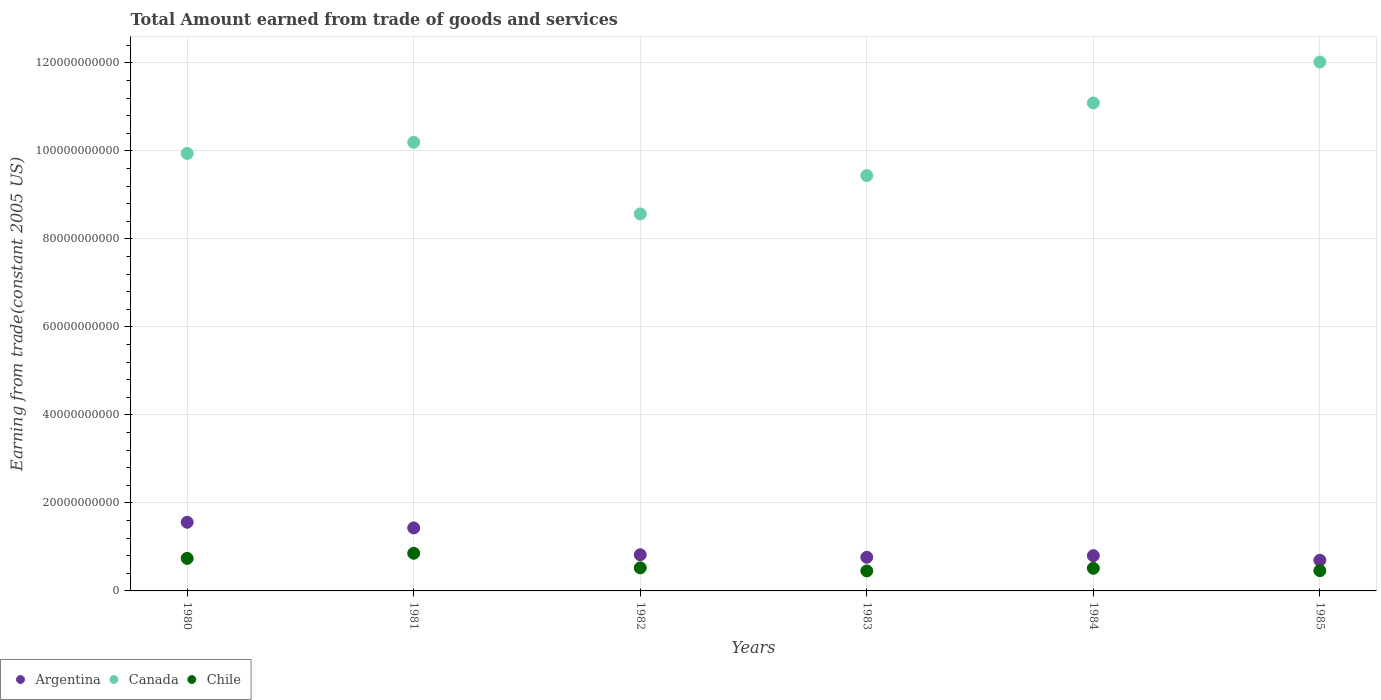What is the total amount earned by trading goods and services in Canada in 1980?
Give a very brief answer. 9.94e+1. Across all years, what is the maximum total amount earned by trading goods and services in Chile?
Ensure brevity in your answer.  8.56e+09. Across all years, what is the minimum total amount earned by trading goods and services in Canada?
Offer a terse response. 8.57e+1. In which year was the total amount earned by trading goods and services in Argentina maximum?
Provide a short and direct response. 1980. What is the total total amount earned by trading goods and services in Argentina in the graph?
Offer a terse response. 6.08e+1. What is the difference between the total amount earned by trading goods and services in Chile in 1980 and that in 1982?
Provide a short and direct response. 2.15e+09. What is the difference between the total amount earned by trading goods and services in Chile in 1984 and the total amount earned by trading goods and services in Canada in 1980?
Ensure brevity in your answer.  -9.43e+1. What is the average total amount earned by trading goods and services in Argentina per year?
Offer a very short reply. 1.01e+1. In the year 1981, what is the difference between the total amount earned by trading goods and services in Argentina and total amount earned by trading goods and services in Chile?
Offer a terse response. 5.76e+09. What is the ratio of the total amount earned by trading goods and services in Canada in 1982 to that in 1984?
Your answer should be very brief. 0.77. What is the difference between the highest and the second highest total amount earned by trading goods and services in Chile?
Provide a short and direct response. 1.16e+09. What is the difference between the highest and the lowest total amount earned by trading goods and services in Argentina?
Make the answer very short. 8.64e+09. Is the sum of the total amount earned by trading goods and services in Canada in 1981 and 1982 greater than the maximum total amount earned by trading goods and services in Chile across all years?
Keep it short and to the point. Yes. Is it the case that in every year, the sum of the total amount earned by trading goods and services in Argentina and total amount earned by trading goods and services in Chile  is greater than the total amount earned by trading goods and services in Canada?
Provide a succinct answer. No. Is the total amount earned by trading goods and services in Canada strictly greater than the total amount earned by trading goods and services in Argentina over the years?
Provide a succinct answer. Yes. How many dotlines are there?
Offer a terse response. 3. Are the values on the major ticks of Y-axis written in scientific E-notation?
Keep it short and to the point. No. Does the graph contain grids?
Give a very brief answer. Yes. How are the legend labels stacked?
Offer a terse response. Horizontal. What is the title of the graph?
Your response must be concise. Total Amount earned from trade of goods and services. What is the label or title of the X-axis?
Provide a short and direct response. Years. What is the label or title of the Y-axis?
Provide a succinct answer. Earning from trade(constant 2005 US). What is the Earning from trade(constant 2005 US) in Argentina in 1980?
Offer a very short reply. 1.56e+1. What is the Earning from trade(constant 2005 US) in Canada in 1980?
Provide a succinct answer. 9.94e+1. What is the Earning from trade(constant 2005 US) of Chile in 1980?
Ensure brevity in your answer.  7.40e+09. What is the Earning from trade(constant 2005 US) in Argentina in 1981?
Offer a very short reply. 1.43e+1. What is the Earning from trade(constant 2005 US) in Canada in 1981?
Your answer should be compact. 1.02e+11. What is the Earning from trade(constant 2005 US) in Chile in 1981?
Give a very brief answer. 8.56e+09. What is the Earning from trade(constant 2005 US) of Argentina in 1982?
Your response must be concise. 8.22e+09. What is the Earning from trade(constant 2005 US) in Canada in 1982?
Provide a short and direct response. 8.57e+1. What is the Earning from trade(constant 2005 US) of Chile in 1982?
Offer a very short reply. 5.24e+09. What is the Earning from trade(constant 2005 US) in Argentina in 1983?
Offer a terse response. 7.65e+09. What is the Earning from trade(constant 2005 US) in Canada in 1983?
Provide a short and direct response. 9.44e+1. What is the Earning from trade(constant 2005 US) in Chile in 1983?
Give a very brief answer. 4.54e+09. What is the Earning from trade(constant 2005 US) of Argentina in 1984?
Offer a very short reply. 8.01e+09. What is the Earning from trade(constant 2005 US) of Canada in 1984?
Ensure brevity in your answer.  1.11e+11. What is the Earning from trade(constant 2005 US) in Chile in 1984?
Your answer should be very brief. 5.14e+09. What is the Earning from trade(constant 2005 US) of Argentina in 1985?
Offer a terse response. 6.97e+09. What is the Earning from trade(constant 2005 US) of Canada in 1985?
Offer a very short reply. 1.20e+11. What is the Earning from trade(constant 2005 US) of Chile in 1985?
Provide a short and direct response. 4.61e+09. Across all years, what is the maximum Earning from trade(constant 2005 US) of Argentina?
Ensure brevity in your answer.  1.56e+1. Across all years, what is the maximum Earning from trade(constant 2005 US) in Canada?
Offer a terse response. 1.20e+11. Across all years, what is the maximum Earning from trade(constant 2005 US) of Chile?
Your answer should be compact. 8.56e+09. Across all years, what is the minimum Earning from trade(constant 2005 US) of Argentina?
Ensure brevity in your answer.  6.97e+09. Across all years, what is the minimum Earning from trade(constant 2005 US) in Canada?
Provide a succinct answer. 8.57e+1. Across all years, what is the minimum Earning from trade(constant 2005 US) of Chile?
Your answer should be very brief. 4.54e+09. What is the total Earning from trade(constant 2005 US) of Argentina in the graph?
Your answer should be compact. 6.08e+1. What is the total Earning from trade(constant 2005 US) in Canada in the graph?
Provide a short and direct response. 6.13e+11. What is the total Earning from trade(constant 2005 US) in Chile in the graph?
Give a very brief answer. 3.55e+1. What is the difference between the Earning from trade(constant 2005 US) in Argentina in 1980 and that in 1981?
Your response must be concise. 1.29e+09. What is the difference between the Earning from trade(constant 2005 US) in Canada in 1980 and that in 1981?
Keep it short and to the point. -2.54e+09. What is the difference between the Earning from trade(constant 2005 US) in Chile in 1980 and that in 1981?
Offer a very short reply. -1.16e+09. What is the difference between the Earning from trade(constant 2005 US) of Argentina in 1980 and that in 1982?
Keep it short and to the point. 7.38e+09. What is the difference between the Earning from trade(constant 2005 US) in Canada in 1980 and that in 1982?
Your response must be concise. 1.37e+1. What is the difference between the Earning from trade(constant 2005 US) in Chile in 1980 and that in 1982?
Provide a succinct answer. 2.15e+09. What is the difference between the Earning from trade(constant 2005 US) of Argentina in 1980 and that in 1983?
Your answer should be compact. 7.95e+09. What is the difference between the Earning from trade(constant 2005 US) of Canada in 1980 and that in 1983?
Offer a very short reply. 5.04e+09. What is the difference between the Earning from trade(constant 2005 US) in Chile in 1980 and that in 1983?
Provide a succinct answer. 2.85e+09. What is the difference between the Earning from trade(constant 2005 US) in Argentina in 1980 and that in 1984?
Your response must be concise. 7.59e+09. What is the difference between the Earning from trade(constant 2005 US) of Canada in 1980 and that in 1984?
Your answer should be very brief. -1.15e+1. What is the difference between the Earning from trade(constant 2005 US) of Chile in 1980 and that in 1984?
Provide a succinct answer. 2.25e+09. What is the difference between the Earning from trade(constant 2005 US) in Argentina in 1980 and that in 1985?
Ensure brevity in your answer.  8.64e+09. What is the difference between the Earning from trade(constant 2005 US) of Canada in 1980 and that in 1985?
Give a very brief answer. -2.08e+1. What is the difference between the Earning from trade(constant 2005 US) of Chile in 1980 and that in 1985?
Offer a very short reply. 2.79e+09. What is the difference between the Earning from trade(constant 2005 US) of Argentina in 1981 and that in 1982?
Make the answer very short. 6.10e+09. What is the difference between the Earning from trade(constant 2005 US) in Canada in 1981 and that in 1982?
Offer a terse response. 1.63e+1. What is the difference between the Earning from trade(constant 2005 US) of Chile in 1981 and that in 1982?
Offer a very short reply. 3.31e+09. What is the difference between the Earning from trade(constant 2005 US) in Argentina in 1981 and that in 1983?
Your answer should be very brief. 6.67e+09. What is the difference between the Earning from trade(constant 2005 US) in Canada in 1981 and that in 1983?
Give a very brief answer. 7.58e+09. What is the difference between the Earning from trade(constant 2005 US) in Chile in 1981 and that in 1983?
Provide a short and direct response. 4.01e+09. What is the difference between the Earning from trade(constant 2005 US) of Argentina in 1981 and that in 1984?
Your answer should be very brief. 6.31e+09. What is the difference between the Earning from trade(constant 2005 US) of Canada in 1981 and that in 1984?
Offer a very short reply. -8.93e+09. What is the difference between the Earning from trade(constant 2005 US) in Chile in 1981 and that in 1984?
Your answer should be compact. 3.42e+09. What is the difference between the Earning from trade(constant 2005 US) of Argentina in 1981 and that in 1985?
Your answer should be compact. 7.35e+09. What is the difference between the Earning from trade(constant 2005 US) in Canada in 1981 and that in 1985?
Ensure brevity in your answer.  -1.82e+1. What is the difference between the Earning from trade(constant 2005 US) of Chile in 1981 and that in 1985?
Give a very brief answer. 3.95e+09. What is the difference between the Earning from trade(constant 2005 US) of Argentina in 1982 and that in 1983?
Give a very brief answer. 5.69e+08. What is the difference between the Earning from trade(constant 2005 US) in Canada in 1982 and that in 1983?
Keep it short and to the point. -8.71e+09. What is the difference between the Earning from trade(constant 2005 US) in Chile in 1982 and that in 1983?
Ensure brevity in your answer.  6.99e+08. What is the difference between the Earning from trade(constant 2005 US) of Argentina in 1982 and that in 1984?
Offer a terse response. 2.09e+08. What is the difference between the Earning from trade(constant 2005 US) in Canada in 1982 and that in 1984?
Your response must be concise. -2.52e+1. What is the difference between the Earning from trade(constant 2005 US) of Chile in 1982 and that in 1984?
Offer a very short reply. 1.01e+08. What is the difference between the Earning from trade(constant 2005 US) in Argentina in 1982 and that in 1985?
Your response must be concise. 1.25e+09. What is the difference between the Earning from trade(constant 2005 US) in Canada in 1982 and that in 1985?
Your response must be concise. -3.45e+1. What is the difference between the Earning from trade(constant 2005 US) in Chile in 1982 and that in 1985?
Your answer should be very brief. 6.32e+08. What is the difference between the Earning from trade(constant 2005 US) in Argentina in 1983 and that in 1984?
Ensure brevity in your answer.  -3.60e+08. What is the difference between the Earning from trade(constant 2005 US) of Canada in 1983 and that in 1984?
Provide a succinct answer. -1.65e+1. What is the difference between the Earning from trade(constant 2005 US) in Chile in 1983 and that in 1984?
Offer a very short reply. -5.98e+08. What is the difference between the Earning from trade(constant 2005 US) of Argentina in 1983 and that in 1985?
Your answer should be compact. 6.85e+08. What is the difference between the Earning from trade(constant 2005 US) of Canada in 1983 and that in 1985?
Give a very brief answer. -2.58e+1. What is the difference between the Earning from trade(constant 2005 US) in Chile in 1983 and that in 1985?
Your answer should be very brief. -6.72e+07. What is the difference between the Earning from trade(constant 2005 US) in Argentina in 1984 and that in 1985?
Offer a terse response. 1.04e+09. What is the difference between the Earning from trade(constant 2005 US) in Canada in 1984 and that in 1985?
Your response must be concise. -9.31e+09. What is the difference between the Earning from trade(constant 2005 US) of Chile in 1984 and that in 1985?
Your answer should be very brief. 5.31e+08. What is the difference between the Earning from trade(constant 2005 US) in Argentina in 1980 and the Earning from trade(constant 2005 US) in Canada in 1981?
Your response must be concise. -8.64e+1. What is the difference between the Earning from trade(constant 2005 US) of Argentina in 1980 and the Earning from trade(constant 2005 US) of Chile in 1981?
Your answer should be compact. 7.05e+09. What is the difference between the Earning from trade(constant 2005 US) of Canada in 1980 and the Earning from trade(constant 2005 US) of Chile in 1981?
Offer a very short reply. 9.09e+1. What is the difference between the Earning from trade(constant 2005 US) in Argentina in 1980 and the Earning from trade(constant 2005 US) in Canada in 1982?
Your answer should be compact. -7.01e+1. What is the difference between the Earning from trade(constant 2005 US) in Argentina in 1980 and the Earning from trade(constant 2005 US) in Chile in 1982?
Provide a succinct answer. 1.04e+1. What is the difference between the Earning from trade(constant 2005 US) in Canada in 1980 and the Earning from trade(constant 2005 US) in Chile in 1982?
Provide a succinct answer. 9.42e+1. What is the difference between the Earning from trade(constant 2005 US) of Argentina in 1980 and the Earning from trade(constant 2005 US) of Canada in 1983?
Make the answer very short. -7.88e+1. What is the difference between the Earning from trade(constant 2005 US) in Argentina in 1980 and the Earning from trade(constant 2005 US) in Chile in 1983?
Keep it short and to the point. 1.11e+1. What is the difference between the Earning from trade(constant 2005 US) in Canada in 1980 and the Earning from trade(constant 2005 US) in Chile in 1983?
Offer a terse response. 9.49e+1. What is the difference between the Earning from trade(constant 2005 US) in Argentina in 1980 and the Earning from trade(constant 2005 US) in Canada in 1984?
Give a very brief answer. -9.53e+1. What is the difference between the Earning from trade(constant 2005 US) in Argentina in 1980 and the Earning from trade(constant 2005 US) in Chile in 1984?
Offer a terse response. 1.05e+1. What is the difference between the Earning from trade(constant 2005 US) of Canada in 1980 and the Earning from trade(constant 2005 US) of Chile in 1984?
Offer a terse response. 9.43e+1. What is the difference between the Earning from trade(constant 2005 US) in Argentina in 1980 and the Earning from trade(constant 2005 US) in Canada in 1985?
Your answer should be very brief. -1.05e+11. What is the difference between the Earning from trade(constant 2005 US) in Argentina in 1980 and the Earning from trade(constant 2005 US) in Chile in 1985?
Offer a terse response. 1.10e+1. What is the difference between the Earning from trade(constant 2005 US) in Canada in 1980 and the Earning from trade(constant 2005 US) in Chile in 1985?
Offer a very short reply. 9.48e+1. What is the difference between the Earning from trade(constant 2005 US) of Argentina in 1981 and the Earning from trade(constant 2005 US) of Canada in 1982?
Offer a terse response. -7.14e+1. What is the difference between the Earning from trade(constant 2005 US) in Argentina in 1981 and the Earning from trade(constant 2005 US) in Chile in 1982?
Ensure brevity in your answer.  9.08e+09. What is the difference between the Earning from trade(constant 2005 US) of Canada in 1981 and the Earning from trade(constant 2005 US) of Chile in 1982?
Ensure brevity in your answer.  9.67e+1. What is the difference between the Earning from trade(constant 2005 US) of Argentina in 1981 and the Earning from trade(constant 2005 US) of Canada in 1983?
Offer a terse response. -8.01e+1. What is the difference between the Earning from trade(constant 2005 US) of Argentina in 1981 and the Earning from trade(constant 2005 US) of Chile in 1983?
Your answer should be very brief. 9.78e+09. What is the difference between the Earning from trade(constant 2005 US) of Canada in 1981 and the Earning from trade(constant 2005 US) of Chile in 1983?
Keep it short and to the point. 9.74e+1. What is the difference between the Earning from trade(constant 2005 US) of Argentina in 1981 and the Earning from trade(constant 2005 US) of Canada in 1984?
Ensure brevity in your answer.  -9.66e+1. What is the difference between the Earning from trade(constant 2005 US) of Argentina in 1981 and the Earning from trade(constant 2005 US) of Chile in 1984?
Provide a succinct answer. 9.18e+09. What is the difference between the Earning from trade(constant 2005 US) of Canada in 1981 and the Earning from trade(constant 2005 US) of Chile in 1984?
Your answer should be compact. 9.68e+1. What is the difference between the Earning from trade(constant 2005 US) of Argentina in 1981 and the Earning from trade(constant 2005 US) of Canada in 1985?
Give a very brief answer. -1.06e+11. What is the difference between the Earning from trade(constant 2005 US) of Argentina in 1981 and the Earning from trade(constant 2005 US) of Chile in 1985?
Your answer should be very brief. 9.71e+09. What is the difference between the Earning from trade(constant 2005 US) of Canada in 1981 and the Earning from trade(constant 2005 US) of Chile in 1985?
Provide a short and direct response. 9.74e+1. What is the difference between the Earning from trade(constant 2005 US) of Argentina in 1982 and the Earning from trade(constant 2005 US) of Canada in 1983?
Provide a succinct answer. -8.62e+1. What is the difference between the Earning from trade(constant 2005 US) of Argentina in 1982 and the Earning from trade(constant 2005 US) of Chile in 1983?
Offer a terse response. 3.68e+09. What is the difference between the Earning from trade(constant 2005 US) of Canada in 1982 and the Earning from trade(constant 2005 US) of Chile in 1983?
Give a very brief answer. 8.11e+1. What is the difference between the Earning from trade(constant 2005 US) in Argentina in 1982 and the Earning from trade(constant 2005 US) in Canada in 1984?
Your answer should be very brief. -1.03e+11. What is the difference between the Earning from trade(constant 2005 US) of Argentina in 1982 and the Earning from trade(constant 2005 US) of Chile in 1984?
Offer a very short reply. 3.08e+09. What is the difference between the Earning from trade(constant 2005 US) of Canada in 1982 and the Earning from trade(constant 2005 US) of Chile in 1984?
Keep it short and to the point. 8.05e+1. What is the difference between the Earning from trade(constant 2005 US) of Argentina in 1982 and the Earning from trade(constant 2005 US) of Canada in 1985?
Give a very brief answer. -1.12e+11. What is the difference between the Earning from trade(constant 2005 US) of Argentina in 1982 and the Earning from trade(constant 2005 US) of Chile in 1985?
Make the answer very short. 3.61e+09. What is the difference between the Earning from trade(constant 2005 US) of Canada in 1982 and the Earning from trade(constant 2005 US) of Chile in 1985?
Give a very brief answer. 8.11e+1. What is the difference between the Earning from trade(constant 2005 US) in Argentina in 1983 and the Earning from trade(constant 2005 US) in Canada in 1984?
Ensure brevity in your answer.  -1.03e+11. What is the difference between the Earning from trade(constant 2005 US) of Argentina in 1983 and the Earning from trade(constant 2005 US) of Chile in 1984?
Offer a very short reply. 2.51e+09. What is the difference between the Earning from trade(constant 2005 US) of Canada in 1983 and the Earning from trade(constant 2005 US) of Chile in 1984?
Provide a succinct answer. 8.93e+1. What is the difference between the Earning from trade(constant 2005 US) of Argentina in 1983 and the Earning from trade(constant 2005 US) of Canada in 1985?
Provide a short and direct response. -1.13e+11. What is the difference between the Earning from trade(constant 2005 US) in Argentina in 1983 and the Earning from trade(constant 2005 US) in Chile in 1985?
Provide a succinct answer. 3.04e+09. What is the difference between the Earning from trade(constant 2005 US) in Canada in 1983 and the Earning from trade(constant 2005 US) in Chile in 1985?
Your answer should be compact. 8.98e+1. What is the difference between the Earning from trade(constant 2005 US) in Argentina in 1984 and the Earning from trade(constant 2005 US) in Canada in 1985?
Ensure brevity in your answer.  -1.12e+11. What is the difference between the Earning from trade(constant 2005 US) in Argentina in 1984 and the Earning from trade(constant 2005 US) in Chile in 1985?
Offer a terse response. 3.40e+09. What is the difference between the Earning from trade(constant 2005 US) in Canada in 1984 and the Earning from trade(constant 2005 US) in Chile in 1985?
Give a very brief answer. 1.06e+11. What is the average Earning from trade(constant 2005 US) in Argentina per year?
Your answer should be compact. 1.01e+1. What is the average Earning from trade(constant 2005 US) of Canada per year?
Make the answer very short. 1.02e+11. What is the average Earning from trade(constant 2005 US) in Chile per year?
Provide a short and direct response. 5.92e+09. In the year 1980, what is the difference between the Earning from trade(constant 2005 US) of Argentina and Earning from trade(constant 2005 US) of Canada?
Ensure brevity in your answer.  -8.38e+1. In the year 1980, what is the difference between the Earning from trade(constant 2005 US) in Argentina and Earning from trade(constant 2005 US) in Chile?
Provide a short and direct response. 8.21e+09. In the year 1980, what is the difference between the Earning from trade(constant 2005 US) in Canada and Earning from trade(constant 2005 US) in Chile?
Make the answer very short. 9.20e+1. In the year 1981, what is the difference between the Earning from trade(constant 2005 US) in Argentina and Earning from trade(constant 2005 US) in Canada?
Provide a succinct answer. -8.77e+1. In the year 1981, what is the difference between the Earning from trade(constant 2005 US) in Argentina and Earning from trade(constant 2005 US) in Chile?
Give a very brief answer. 5.76e+09. In the year 1981, what is the difference between the Earning from trade(constant 2005 US) in Canada and Earning from trade(constant 2005 US) in Chile?
Provide a succinct answer. 9.34e+1. In the year 1982, what is the difference between the Earning from trade(constant 2005 US) of Argentina and Earning from trade(constant 2005 US) of Canada?
Keep it short and to the point. -7.75e+1. In the year 1982, what is the difference between the Earning from trade(constant 2005 US) of Argentina and Earning from trade(constant 2005 US) of Chile?
Your answer should be compact. 2.98e+09. In the year 1982, what is the difference between the Earning from trade(constant 2005 US) in Canada and Earning from trade(constant 2005 US) in Chile?
Give a very brief answer. 8.04e+1. In the year 1983, what is the difference between the Earning from trade(constant 2005 US) of Argentina and Earning from trade(constant 2005 US) of Canada?
Ensure brevity in your answer.  -8.67e+1. In the year 1983, what is the difference between the Earning from trade(constant 2005 US) of Argentina and Earning from trade(constant 2005 US) of Chile?
Your answer should be compact. 3.11e+09. In the year 1983, what is the difference between the Earning from trade(constant 2005 US) of Canada and Earning from trade(constant 2005 US) of Chile?
Your response must be concise. 8.99e+1. In the year 1984, what is the difference between the Earning from trade(constant 2005 US) of Argentina and Earning from trade(constant 2005 US) of Canada?
Give a very brief answer. -1.03e+11. In the year 1984, what is the difference between the Earning from trade(constant 2005 US) in Argentina and Earning from trade(constant 2005 US) in Chile?
Ensure brevity in your answer.  2.87e+09. In the year 1984, what is the difference between the Earning from trade(constant 2005 US) of Canada and Earning from trade(constant 2005 US) of Chile?
Ensure brevity in your answer.  1.06e+11. In the year 1985, what is the difference between the Earning from trade(constant 2005 US) in Argentina and Earning from trade(constant 2005 US) in Canada?
Give a very brief answer. -1.13e+11. In the year 1985, what is the difference between the Earning from trade(constant 2005 US) of Argentina and Earning from trade(constant 2005 US) of Chile?
Ensure brevity in your answer.  2.36e+09. In the year 1985, what is the difference between the Earning from trade(constant 2005 US) of Canada and Earning from trade(constant 2005 US) of Chile?
Your response must be concise. 1.16e+11. What is the ratio of the Earning from trade(constant 2005 US) in Argentina in 1980 to that in 1981?
Give a very brief answer. 1.09. What is the ratio of the Earning from trade(constant 2005 US) in Canada in 1980 to that in 1981?
Offer a terse response. 0.98. What is the ratio of the Earning from trade(constant 2005 US) in Chile in 1980 to that in 1981?
Make the answer very short. 0.86. What is the ratio of the Earning from trade(constant 2005 US) in Argentina in 1980 to that in 1982?
Give a very brief answer. 1.9. What is the ratio of the Earning from trade(constant 2005 US) of Canada in 1980 to that in 1982?
Offer a terse response. 1.16. What is the ratio of the Earning from trade(constant 2005 US) of Chile in 1980 to that in 1982?
Give a very brief answer. 1.41. What is the ratio of the Earning from trade(constant 2005 US) in Argentina in 1980 to that in 1983?
Provide a short and direct response. 2.04. What is the ratio of the Earning from trade(constant 2005 US) in Canada in 1980 to that in 1983?
Provide a succinct answer. 1.05. What is the ratio of the Earning from trade(constant 2005 US) in Chile in 1980 to that in 1983?
Provide a succinct answer. 1.63. What is the ratio of the Earning from trade(constant 2005 US) of Argentina in 1980 to that in 1984?
Your answer should be compact. 1.95. What is the ratio of the Earning from trade(constant 2005 US) of Canada in 1980 to that in 1984?
Make the answer very short. 0.9. What is the ratio of the Earning from trade(constant 2005 US) in Chile in 1980 to that in 1984?
Offer a very short reply. 1.44. What is the ratio of the Earning from trade(constant 2005 US) in Argentina in 1980 to that in 1985?
Your answer should be compact. 2.24. What is the ratio of the Earning from trade(constant 2005 US) of Canada in 1980 to that in 1985?
Ensure brevity in your answer.  0.83. What is the ratio of the Earning from trade(constant 2005 US) of Chile in 1980 to that in 1985?
Keep it short and to the point. 1.6. What is the ratio of the Earning from trade(constant 2005 US) of Argentina in 1981 to that in 1982?
Keep it short and to the point. 1.74. What is the ratio of the Earning from trade(constant 2005 US) of Canada in 1981 to that in 1982?
Your answer should be very brief. 1.19. What is the ratio of the Earning from trade(constant 2005 US) of Chile in 1981 to that in 1982?
Ensure brevity in your answer.  1.63. What is the ratio of the Earning from trade(constant 2005 US) in Argentina in 1981 to that in 1983?
Your answer should be very brief. 1.87. What is the ratio of the Earning from trade(constant 2005 US) in Canada in 1981 to that in 1983?
Ensure brevity in your answer.  1.08. What is the ratio of the Earning from trade(constant 2005 US) of Chile in 1981 to that in 1983?
Your answer should be very brief. 1.88. What is the ratio of the Earning from trade(constant 2005 US) in Argentina in 1981 to that in 1984?
Your response must be concise. 1.79. What is the ratio of the Earning from trade(constant 2005 US) of Canada in 1981 to that in 1984?
Make the answer very short. 0.92. What is the ratio of the Earning from trade(constant 2005 US) of Chile in 1981 to that in 1984?
Ensure brevity in your answer.  1.66. What is the ratio of the Earning from trade(constant 2005 US) in Argentina in 1981 to that in 1985?
Your response must be concise. 2.05. What is the ratio of the Earning from trade(constant 2005 US) of Canada in 1981 to that in 1985?
Make the answer very short. 0.85. What is the ratio of the Earning from trade(constant 2005 US) of Chile in 1981 to that in 1985?
Your answer should be very brief. 1.86. What is the ratio of the Earning from trade(constant 2005 US) in Argentina in 1982 to that in 1983?
Your response must be concise. 1.07. What is the ratio of the Earning from trade(constant 2005 US) in Canada in 1982 to that in 1983?
Your response must be concise. 0.91. What is the ratio of the Earning from trade(constant 2005 US) of Chile in 1982 to that in 1983?
Ensure brevity in your answer.  1.15. What is the ratio of the Earning from trade(constant 2005 US) in Argentina in 1982 to that in 1984?
Provide a short and direct response. 1.03. What is the ratio of the Earning from trade(constant 2005 US) in Canada in 1982 to that in 1984?
Your answer should be very brief. 0.77. What is the ratio of the Earning from trade(constant 2005 US) in Chile in 1982 to that in 1984?
Ensure brevity in your answer.  1.02. What is the ratio of the Earning from trade(constant 2005 US) in Argentina in 1982 to that in 1985?
Keep it short and to the point. 1.18. What is the ratio of the Earning from trade(constant 2005 US) of Canada in 1982 to that in 1985?
Provide a succinct answer. 0.71. What is the ratio of the Earning from trade(constant 2005 US) of Chile in 1982 to that in 1985?
Offer a terse response. 1.14. What is the ratio of the Earning from trade(constant 2005 US) in Argentina in 1983 to that in 1984?
Provide a short and direct response. 0.96. What is the ratio of the Earning from trade(constant 2005 US) of Canada in 1983 to that in 1984?
Your response must be concise. 0.85. What is the ratio of the Earning from trade(constant 2005 US) of Chile in 1983 to that in 1984?
Your response must be concise. 0.88. What is the ratio of the Earning from trade(constant 2005 US) of Argentina in 1983 to that in 1985?
Offer a very short reply. 1.1. What is the ratio of the Earning from trade(constant 2005 US) of Canada in 1983 to that in 1985?
Keep it short and to the point. 0.79. What is the ratio of the Earning from trade(constant 2005 US) of Chile in 1983 to that in 1985?
Offer a very short reply. 0.99. What is the ratio of the Earning from trade(constant 2005 US) in Argentina in 1984 to that in 1985?
Make the answer very short. 1.15. What is the ratio of the Earning from trade(constant 2005 US) in Canada in 1984 to that in 1985?
Ensure brevity in your answer.  0.92. What is the ratio of the Earning from trade(constant 2005 US) in Chile in 1984 to that in 1985?
Offer a terse response. 1.12. What is the difference between the highest and the second highest Earning from trade(constant 2005 US) in Argentina?
Give a very brief answer. 1.29e+09. What is the difference between the highest and the second highest Earning from trade(constant 2005 US) of Canada?
Offer a terse response. 9.31e+09. What is the difference between the highest and the second highest Earning from trade(constant 2005 US) of Chile?
Offer a very short reply. 1.16e+09. What is the difference between the highest and the lowest Earning from trade(constant 2005 US) of Argentina?
Provide a succinct answer. 8.64e+09. What is the difference between the highest and the lowest Earning from trade(constant 2005 US) in Canada?
Offer a terse response. 3.45e+1. What is the difference between the highest and the lowest Earning from trade(constant 2005 US) in Chile?
Keep it short and to the point. 4.01e+09. 